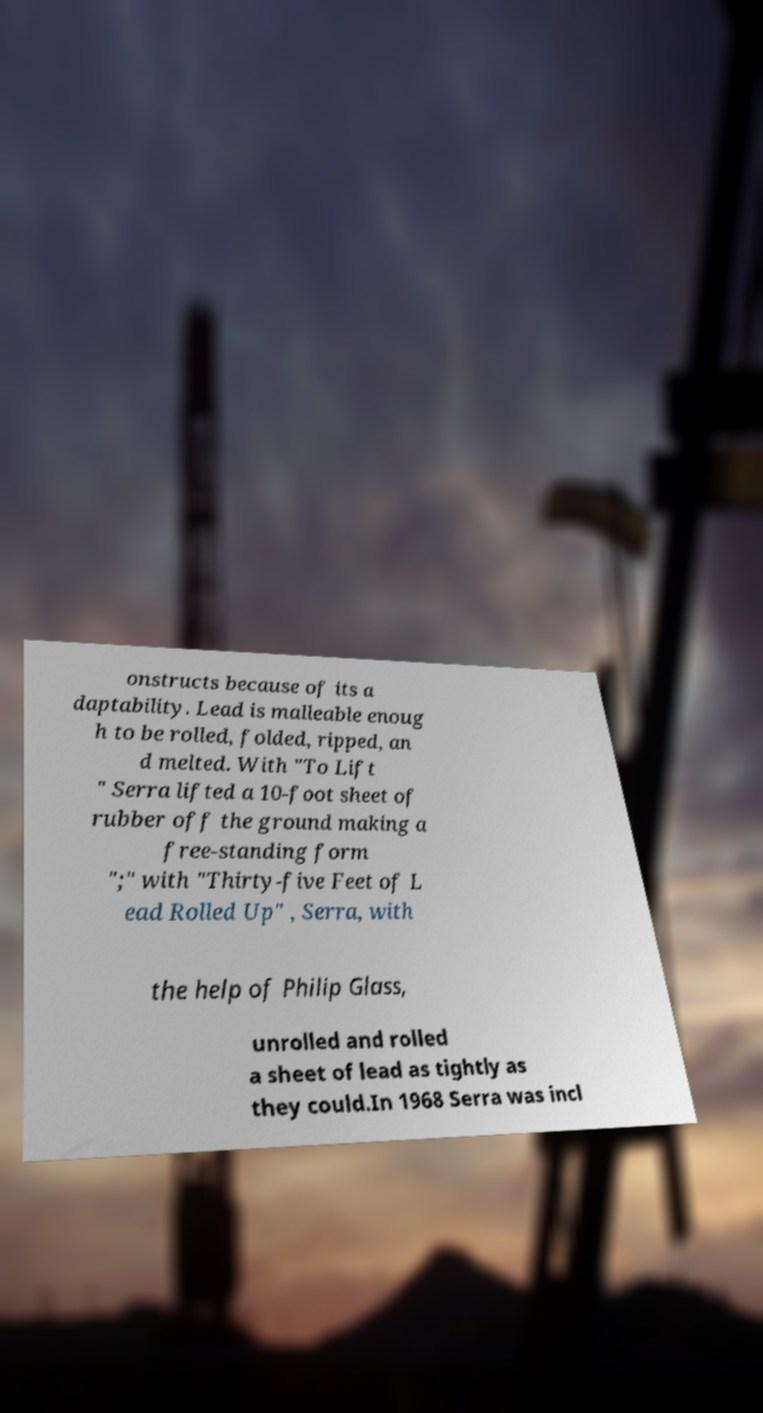There's text embedded in this image that I need extracted. Can you transcribe it verbatim? onstructs because of its a daptability. Lead is malleable enoug h to be rolled, folded, ripped, an d melted. With "To Lift " Serra lifted a 10-foot sheet of rubber off the ground making a free-standing form ";" with "Thirty-five Feet of L ead Rolled Up" , Serra, with the help of Philip Glass, unrolled and rolled a sheet of lead as tightly as they could.In 1968 Serra was incl 